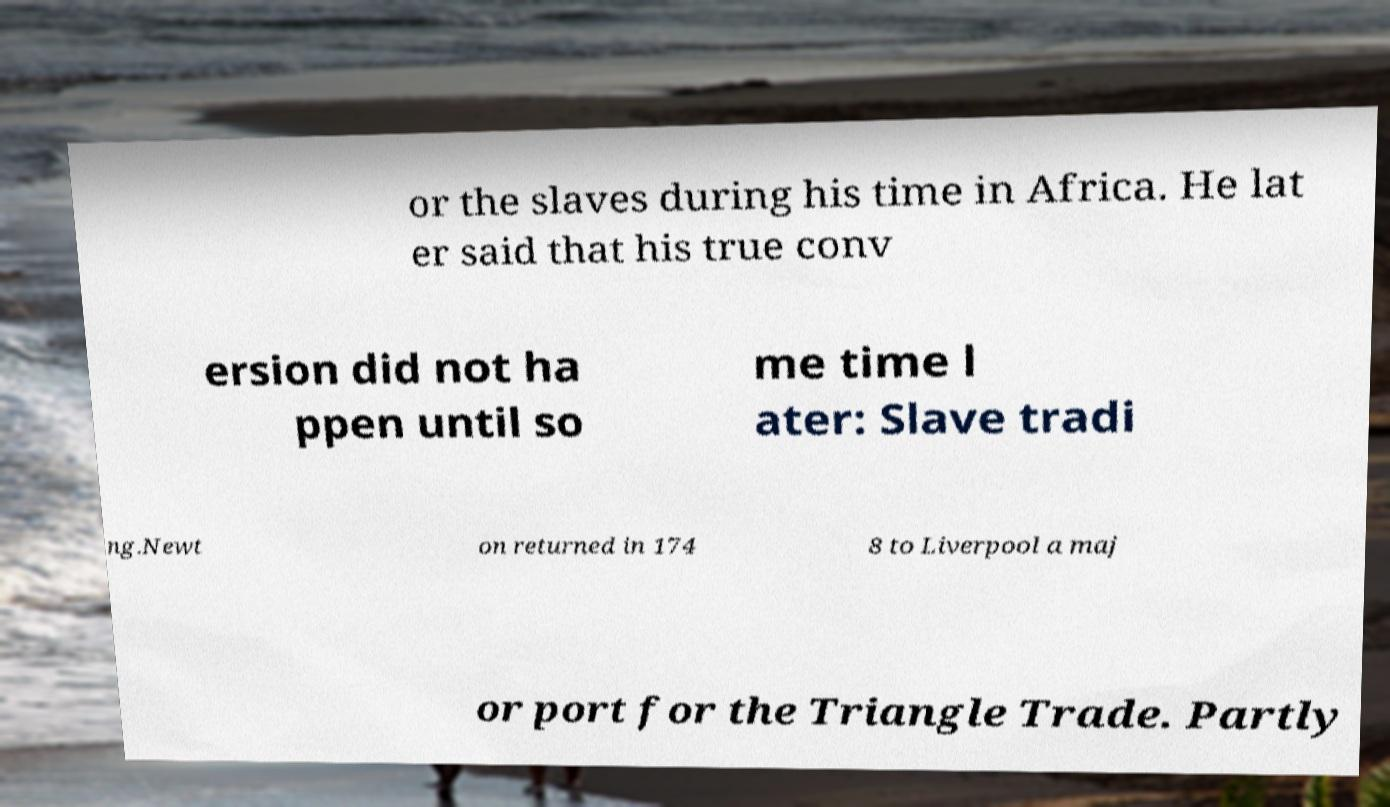For documentation purposes, I need the text within this image transcribed. Could you provide that? or the slaves during his time in Africa. He lat er said that his true conv ersion did not ha ppen until so me time l ater: Slave tradi ng.Newt on returned in 174 8 to Liverpool a maj or port for the Triangle Trade. Partly 